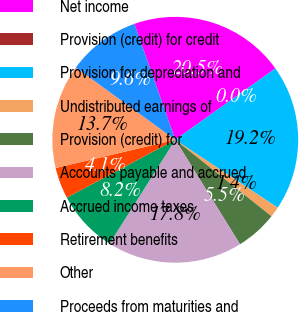<chart> <loc_0><loc_0><loc_500><loc_500><pie_chart><fcel>Net income<fcel>Provision (credit) for credit<fcel>Provision for depreciation and<fcel>Undistributed earnings of<fcel>Provision (credit) for<fcel>Accounts payable and accrued<fcel>Accrued income taxes<fcel>Retirement benefits<fcel>Other<fcel>Proceeds from maturities and<nl><fcel>20.55%<fcel>0.0%<fcel>19.18%<fcel>1.37%<fcel>5.48%<fcel>17.81%<fcel>8.22%<fcel>4.11%<fcel>13.7%<fcel>9.59%<nl></chart> 